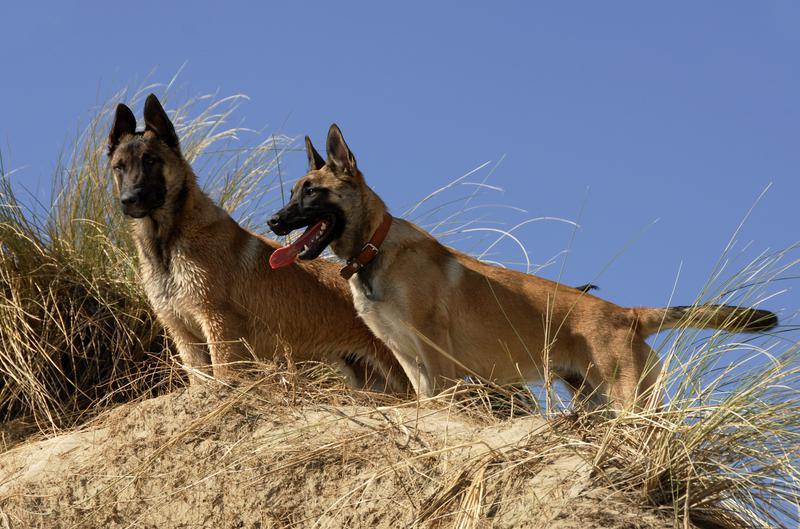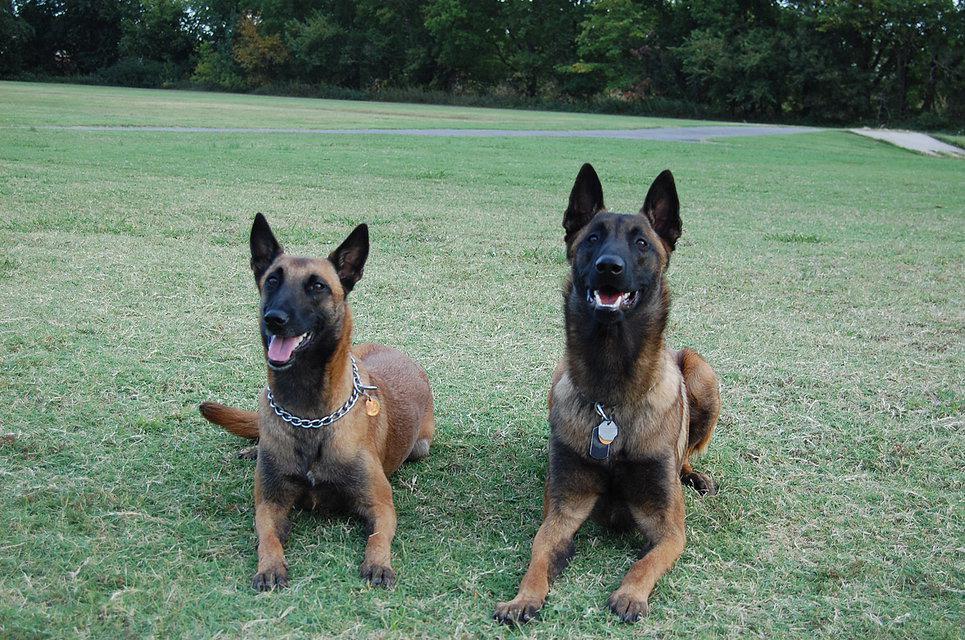The first image is the image on the left, the second image is the image on the right. Assess this claim about the two images: "There are 2 or more German Shepard's laying down on grass.". Correct or not? Answer yes or no. Yes. The first image is the image on the left, the second image is the image on the right. For the images displayed, is the sentence "At least two dogs are lying down on the ground." factually correct? Answer yes or no. Yes. 